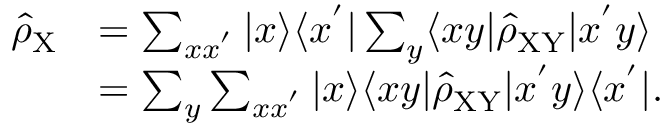<formula> <loc_0><loc_0><loc_500><loc_500>\begin{array} { r l } { \hat { \rho } _ { X } } & { = \sum _ { x x ^ { ^ { \prime } } } | x \rangle \langle x ^ { ^ { \prime } } | \sum _ { y } \langle x y | \hat { \rho } _ { X Y } | x ^ { ^ { \prime } } y \rangle } \\ & { = \sum _ { y } \sum _ { x x ^ { ^ { \prime } } } | x \rangle \langle x y | \hat { \rho } _ { X Y } | x ^ { ^ { \prime } } y \rangle \langle x ^ { ^ { \prime } } | . } \end{array}</formula> 